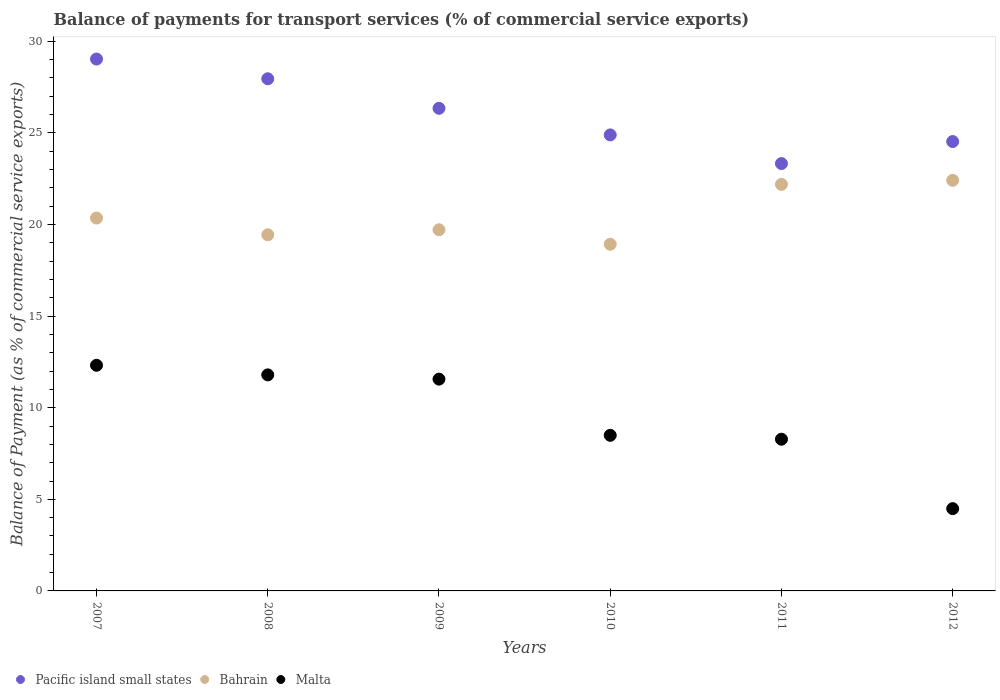How many different coloured dotlines are there?
Ensure brevity in your answer.  3. Is the number of dotlines equal to the number of legend labels?
Your answer should be very brief. Yes. What is the balance of payments for transport services in Bahrain in 2009?
Your answer should be compact. 19.72. Across all years, what is the maximum balance of payments for transport services in Pacific island small states?
Ensure brevity in your answer.  29.03. Across all years, what is the minimum balance of payments for transport services in Bahrain?
Your answer should be very brief. 18.92. In which year was the balance of payments for transport services in Malta maximum?
Provide a short and direct response. 2007. What is the total balance of payments for transport services in Bahrain in the graph?
Provide a short and direct response. 123.04. What is the difference between the balance of payments for transport services in Bahrain in 2008 and that in 2011?
Ensure brevity in your answer.  -2.75. What is the difference between the balance of payments for transport services in Pacific island small states in 2008 and the balance of payments for transport services in Bahrain in 2010?
Provide a short and direct response. 9.03. What is the average balance of payments for transport services in Malta per year?
Offer a very short reply. 9.49. In the year 2008, what is the difference between the balance of payments for transport services in Pacific island small states and balance of payments for transport services in Bahrain?
Make the answer very short. 8.52. What is the ratio of the balance of payments for transport services in Pacific island small states in 2007 to that in 2009?
Give a very brief answer. 1.1. What is the difference between the highest and the second highest balance of payments for transport services in Bahrain?
Make the answer very short. 0.22. What is the difference between the highest and the lowest balance of payments for transport services in Bahrain?
Provide a short and direct response. 3.49. Is the balance of payments for transport services in Bahrain strictly greater than the balance of payments for transport services in Malta over the years?
Provide a short and direct response. Yes. Is the balance of payments for transport services in Malta strictly less than the balance of payments for transport services in Pacific island small states over the years?
Your answer should be compact. Yes. What is the difference between two consecutive major ticks on the Y-axis?
Give a very brief answer. 5. Are the values on the major ticks of Y-axis written in scientific E-notation?
Make the answer very short. No. Where does the legend appear in the graph?
Make the answer very short. Bottom left. How many legend labels are there?
Offer a very short reply. 3. What is the title of the graph?
Your answer should be compact. Balance of payments for transport services (% of commercial service exports). Does "Togo" appear as one of the legend labels in the graph?
Keep it short and to the point. No. What is the label or title of the Y-axis?
Ensure brevity in your answer.  Balance of Payment (as % of commercial service exports). What is the Balance of Payment (as % of commercial service exports) of Pacific island small states in 2007?
Your response must be concise. 29.03. What is the Balance of Payment (as % of commercial service exports) in Bahrain in 2007?
Your answer should be very brief. 20.35. What is the Balance of Payment (as % of commercial service exports) of Malta in 2007?
Provide a short and direct response. 12.32. What is the Balance of Payment (as % of commercial service exports) in Pacific island small states in 2008?
Offer a terse response. 27.96. What is the Balance of Payment (as % of commercial service exports) in Bahrain in 2008?
Offer a terse response. 19.44. What is the Balance of Payment (as % of commercial service exports) of Malta in 2008?
Keep it short and to the point. 11.79. What is the Balance of Payment (as % of commercial service exports) in Pacific island small states in 2009?
Your answer should be very brief. 26.34. What is the Balance of Payment (as % of commercial service exports) in Bahrain in 2009?
Your answer should be compact. 19.72. What is the Balance of Payment (as % of commercial service exports) in Malta in 2009?
Provide a succinct answer. 11.56. What is the Balance of Payment (as % of commercial service exports) of Pacific island small states in 2010?
Give a very brief answer. 24.89. What is the Balance of Payment (as % of commercial service exports) of Bahrain in 2010?
Make the answer very short. 18.92. What is the Balance of Payment (as % of commercial service exports) of Malta in 2010?
Your response must be concise. 8.49. What is the Balance of Payment (as % of commercial service exports) in Pacific island small states in 2011?
Offer a terse response. 23.33. What is the Balance of Payment (as % of commercial service exports) in Bahrain in 2011?
Your answer should be compact. 22.19. What is the Balance of Payment (as % of commercial service exports) in Malta in 2011?
Ensure brevity in your answer.  8.28. What is the Balance of Payment (as % of commercial service exports) of Pacific island small states in 2012?
Provide a short and direct response. 24.53. What is the Balance of Payment (as % of commercial service exports) in Bahrain in 2012?
Make the answer very short. 22.41. What is the Balance of Payment (as % of commercial service exports) in Malta in 2012?
Your answer should be compact. 4.49. Across all years, what is the maximum Balance of Payment (as % of commercial service exports) in Pacific island small states?
Offer a very short reply. 29.03. Across all years, what is the maximum Balance of Payment (as % of commercial service exports) in Bahrain?
Make the answer very short. 22.41. Across all years, what is the maximum Balance of Payment (as % of commercial service exports) of Malta?
Keep it short and to the point. 12.32. Across all years, what is the minimum Balance of Payment (as % of commercial service exports) of Pacific island small states?
Give a very brief answer. 23.33. Across all years, what is the minimum Balance of Payment (as % of commercial service exports) in Bahrain?
Your answer should be very brief. 18.92. Across all years, what is the minimum Balance of Payment (as % of commercial service exports) of Malta?
Keep it short and to the point. 4.49. What is the total Balance of Payment (as % of commercial service exports) of Pacific island small states in the graph?
Your response must be concise. 156.09. What is the total Balance of Payment (as % of commercial service exports) in Bahrain in the graph?
Make the answer very short. 123.04. What is the total Balance of Payment (as % of commercial service exports) of Malta in the graph?
Provide a succinct answer. 56.94. What is the difference between the Balance of Payment (as % of commercial service exports) in Pacific island small states in 2007 and that in 2008?
Give a very brief answer. 1.08. What is the difference between the Balance of Payment (as % of commercial service exports) of Bahrain in 2007 and that in 2008?
Offer a very short reply. 0.92. What is the difference between the Balance of Payment (as % of commercial service exports) of Malta in 2007 and that in 2008?
Offer a terse response. 0.52. What is the difference between the Balance of Payment (as % of commercial service exports) of Pacific island small states in 2007 and that in 2009?
Make the answer very short. 2.69. What is the difference between the Balance of Payment (as % of commercial service exports) in Bahrain in 2007 and that in 2009?
Offer a very short reply. 0.64. What is the difference between the Balance of Payment (as % of commercial service exports) of Malta in 2007 and that in 2009?
Provide a short and direct response. 0.76. What is the difference between the Balance of Payment (as % of commercial service exports) in Pacific island small states in 2007 and that in 2010?
Offer a very short reply. 4.14. What is the difference between the Balance of Payment (as % of commercial service exports) in Bahrain in 2007 and that in 2010?
Give a very brief answer. 1.43. What is the difference between the Balance of Payment (as % of commercial service exports) of Malta in 2007 and that in 2010?
Your answer should be compact. 3.82. What is the difference between the Balance of Payment (as % of commercial service exports) of Pacific island small states in 2007 and that in 2011?
Your response must be concise. 5.71. What is the difference between the Balance of Payment (as % of commercial service exports) in Bahrain in 2007 and that in 2011?
Make the answer very short. -1.84. What is the difference between the Balance of Payment (as % of commercial service exports) of Malta in 2007 and that in 2011?
Offer a terse response. 4.04. What is the difference between the Balance of Payment (as % of commercial service exports) of Pacific island small states in 2007 and that in 2012?
Your answer should be very brief. 4.5. What is the difference between the Balance of Payment (as % of commercial service exports) of Bahrain in 2007 and that in 2012?
Ensure brevity in your answer.  -2.06. What is the difference between the Balance of Payment (as % of commercial service exports) of Malta in 2007 and that in 2012?
Provide a succinct answer. 7.83. What is the difference between the Balance of Payment (as % of commercial service exports) in Pacific island small states in 2008 and that in 2009?
Keep it short and to the point. 1.61. What is the difference between the Balance of Payment (as % of commercial service exports) of Bahrain in 2008 and that in 2009?
Your answer should be compact. -0.28. What is the difference between the Balance of Payment (as % of commercial service exports) of Malta in 2008 and that in 2009?
Give a very brief answer. 0.23. What is the difference between the Balance of Payment (as % of commercial service exports) of Pacific island small states in 2008 and that in 2010?
Your answer should be very brief. 3.06. What is the difference between the Balance of Payment (as % of commercial service exports) in Bahrain in 2008 and that in 2010?
Offer a very short reply. 0.52. What is the difference between the Balance of Payment (as % of commercial service exports) of Malta in 2008 and that in 2010?
Provide a succinct answer. 3.3. What is the difference between the Balance of Payment (as % of commercial service exports) in Pacific island small states in 2008 and that in 2011?
Offer a terse response. 4.63. What is the difference between the Balance of Payment (as % of commercial service exports) of Bahrain in 2008 and that in 2011?
Make the answer very short. -2.75. What is the difference between the Balance of Payment (as % of commercial service exports) in Malta in 2008 and that in 2011?
Keep it short and to the point. 3.51. What is the difference between the Balance of Payment (as % of commercial service exports) in Pacific island small states in 2008 and that in 2012?
Keep it short and to the point. 3.43. What is the difference between the Balance of Payment (as % of commercial service exports) in Bahrain in 2008 and that in 2012?
Your response must be concise. -2.97. What is the difference between the Balance of Payment (as % of commercial service exports) in Malta in 2008 and that in 2012?
Keep it short and to the point. 7.3. What is the difference between the Balance of Payment (as % of commercial service exports) of Pacific island small states in 2009 and that in 2010?
Give a very brief answer. 1.45. What is the difference between the Balance of Payment (as % of commercial service exports) of Bahrain in 2009 and that in 2010?
Provide a short and direct response. 0.79. What is the difference between the Balance of Payment (as % of commercial service exports) of Malta in 2009 and that in 2010?
Ensure brevity in your answer.  3.07. What is the difference between the Balance of Payment (as % of commercial service exports) of Pacific island small states in 2009 and that in 2011?
Your answer should be compact. 3.02. What is the difference between the Balance of Payment (as % of commercial service exports) of Bahrain in 2009 and that in 2011?
Provide a succinct answer. -2.48. What is the difference between the Balance of Payment (as % of commercial service exports) of Malta in 2009 and that in 2011?
Provide a short and direct response. 3.28. What is the difference between the Balance of Payment (as % of commercial service exports) in Pacific island small states in 2009 and that in 2012?
Keep it short and to the point. 1.81. What is the difference between the Balance of Payment (as % of commercial service exports) of Bahrain in 2009 and that in 2012?
Your answer should be compact. -2.7. What is the difference between the Balance of Payment (as % of commercial service exports) in Malta in 2009 and that in 2012?
Ensure brevity in your answer.  7.07. What is the difference between the Balance of Payment (as % of commercial service exports) in Pacific island small states in 2010 and that in 2011?
Provide a short and direct response. 1.56. What is the difference between the Balance of Payment (as % of commercial service exports) in Bahrain in 2010 and that in 2011?
Make the answer very short. -3.27. What is the difference between the Balance of Payment (as % of commercial service exports) of Malta in 2010 and that in 2011?
Your answer should be very brief. 0.21. What is the difference between the Balance of Payment (as % of commercial service exports) in Pacific island small states in 2010 and that in 2012?
Ensure brevity in your answer.  0.36. What is the difference between the Balance of Payment (as % of commercial service exports) in Bahrain in 2010 and that in 2012?
Your answer should be compact. -3.49. What is the difference between the Balance of Payment (as % of commercial service exports) in Malta in 2010 and that in 2012?
Ensure brevity in your answer.  4. What is the difference between the Balance of Payment (as % of commercial service exports) of Pacific island small states in 2011 and that in 2012?
Offer a terse response. -1.2. What is the difference between the Balance of Payment (as % of commercial service exports) of Bahrain in 2011 and that in 2012?
Give a very brief answer. -0.22. What is the difference between the Balance of Payment (as % of commercial service exports) of Malta in 2011 and that in 2012?
Offer a very short reply. 3.79. What is the difference between the Balance of Payment (as % of commercial service exports) in Pacific island small states in 2007 and the Balance of Payment (as % of commercial service exports) in Bahrain in 2008?
Provide a succinct answer. 9.59. What is the difference between the Balance of Payment (as % of commercial service exports) of Pacific island small states in 2007 and the Balance of Payment (as % of commercial service exports) of Malta in 2008?
Ensure brevity in your answer.  17.24. What is the difference between the Balance of Payment (as % of commercial service exports) in Bahrain in 2007 and the Balance of Payment (as % of commercial service exports) in Malta in 2008?
Offer a terse response. 8.56. What is the difference between the Balance of Payment (as % of commercial service exports) of Pacific island small states in 2007 and the Balance of Payment (as % of commercial service exports) of Bahrain in 2009?
Offer a very short reply. 9.32. What is the difference between the Balance of Payment (as % of commercial service exports) in Pacific island small states in 2007 and the Balance of Payment (as % of commercial service exports) in Malta in 2009?
Keep it short and to the point. 17.47. What is the difference between the Balance of Payment (as % of commercial service exports) in Bahrain in 2007 and the Balance of Payment (as % of commercial service exports) in Malta in 2009?
Your response must be concise. 8.79. What is the difference between the Balance of Payment (as % of commercial service exports) in Pacific island small states in 2007 and the Balance of Payment (as % of commercial service exports) in Bahrain in 2010?
Offer a terse response. 10.11. What is the difference between the Balance of Payment (as % of commercial service exports) of Pacific island small states in 2007 and the Balance of Payment (as % of commercial service exports) of Malta in 2010?
Ensure brevity in your answer.  20.54. What is the difference between the Balance of Payment (as % of commercial service exports) in Bahrain in 2007 and the Balance of Payment (as % of commercial service exports) in Malta in 2010?
Your answer should be very brief. 11.86. What is the difference between the Balance of Payment (as % of commercial service exports) in Pacific island small states in 2007 and the Balance of Payment (as % of commercial service exports) in Bahrain in 2011?
Provide a short and direct response. 6.84. What is the difference between the Balance of Payment (as % of commercial service exports) of Pacific island small states in 2007 and the Balance of Payment (as % of commercial service exports) of Malta in 2011?
Give a very brief answer. 20.75. What is the difference between the Balance of Payment (as % of commercial service exports) in Bahrain in 2007 and the Balance of Payment (as % of commercial service exports) in Malta in 2011?
Give a very brief answer. 12.07. What is the difference between the Balance of Payment (as % of commercial service exports) of Pacific island small states in 2007 and the Balance of Payment (as % of commercial service exports) of Bahrain in 2012?
Give a very brief answer. 6.62. What is the difference between the Balance of Payment (as % of commercial service exports) of Pacific island small states in 2007 and the Balance of Payment (as % of commercial service exports) of Malta in 2012?
Your answer should be compact. 24.54. What is the difference between the Balance of Payment (as % of commercial service exports) of Bahrain in 2007 and the Balance of Payment (as % of commercial service exports) of Malta in 2012?
Offer a very short reply. 15.86. What is the difference between the Balance of Payment (as % of commercial service exports) of Pacific island small states in 2008 and the Balance of Payment (as % of commercial service exports) of Bahrain in 2009?
Make the answer very short. 8.24. What is the difference between the Balance of Payment (as % of commercial service exports) in Pacific island small states in 2008 and the Balance of Payment (as % of commercial service exports) in Malta in 2009?
Offer a very short reply. 16.4. What is the difference between the Balance of Payment (as % of commercial service exports) of Bahrain in 2008 and the Balance of Payment (as % of commercial service exports) of Malta in 2009?
Keep it short and to the point. 7.88. What is the difference between the Balance of Payment (as % of commercial service exports) in Pacific island small states in 2008 and the Balance of Payment (as % of commercial service exports) in Bahrain in 2010?
Your response must be concise. 9.03. What is the difference between the Balance of Payment (as % of commercial service exports) of Pacific island small states in 2008 and the Balance of Payment (as % of commercial service exports) of Malta in 2010?
Offer a terse response. 19.46. What is the difference between the Balance of Payment (as % of commercial service exports) in Bahrain in 2008 and the Balance of Payment (as % of commercial service exports) in Malta in 2010?
Give a very brief answer. 10.94. What is the difference between the Balance of Payment (as % of commercial service exports) of Pacific island small states in 2008 and the Balance of Payment (as % of commercial service exports) of Bahrain in 2011?
Your answer should be compact. 5.77. What is the difference between the Balance of Payment (as % of commercial service exports) of Pacific island small states in 2008 and the Balance of Payment (as % of commercial service exports) of Malta in 2011?
Keep it short and to the point. 19.68. What is the difference between the Balance of Payment (as % of commercial service exports) in Bahrain in 2008 and the Balance of Payment (as % of commercial service exports) in Malta in 2011?
Provide a succinct answer. 11.16. What is the difference between the Balance of Payment (as % of commercial service exports) of Pacific island small states in 2008 and the Balance of Payment (as % of commercial service exports) of Bahrain in 2012?
Ensure brevity in your answer.  5.54. What is the difference between the Balance of Payment (as % of commercial service exports) in Pacific island small states in 2008 and the Balance of Payment (as % of commercial service exports) in Malta in 2012?
Make the answer very short. 23.47. What is the difference between the Balance of Payment (as % of commercial service exports) in Bahrain in 2008 and the Balance of Payment (as % of commercial service exports) in Malta in 2012?
Offer a terse response. 14.95. What is the difference between the Balance of Payment (as % of commercial service exports) of Pacific island small states in 2009 and the Balance of Payment (as % of commercial service exports) of Bahrain in 2010?
Ensure brevity in your answer.  7.42. What is the difference between the Balance of Payment (as % of commercial service exports) of Pacific island small states in 2009 and the Balance of Payment (as % of commercial service exports) of Malta in 2010?
Ensure brevity in your answer.  17.85. What is the difference between the Balance of Payment (as % of commercial service exports) in Bahrain in 2009 and the Balance of Payment (as % of commercial service exports) in Malta in 2010?
Provide a short and direct response. 11.22. What is the difference between the Balance of Payment (as % of commercial service exports) in Pacific island small states in 2009 and the Balance of Payment (as % of commercial service exports) in Bahrain in 2011?
Provide a succinct answer. 4.15. What is the difference between the Balance of Payment (as % of commercial service exports) of Pacific island small states in 2009 and the Balance of Payment (as % of commercial service exports) of Malta in 2011?
Offer a terse response. 18.06. What is the difference between the Balance of Payment (as % of commercial service exports) in Bahrain in 2009 and the Balance of Payment (as % of commercial service exports) in Malta in 2011?
Make the answer very short. 11.43. What is the difference between the Balance of Payment (as % of commercial service exports) in Pacific island small states in 2009 and the Balance of Payment (as % of commercial service exports) in Bahrain in 2012?
Give a very brief answer. 3.93. What is the difference between the Balance of Payment (as % of commercial service exports) in Pacific island small states in 2009 and the Balance of Payment (as % of commercial service exports) in Malta in 2012?
Ensure brevity in your answer.  21.85. What is the difference between the Balance of Payment (as % of commercial service exports) in Bahrain in 2009 and the Balance of Payment (as % of commercial service exports) in Malta in 2012?
Your answer should be compact. 15.22. What is the difference between the Balance of Payment (as % of commercial service exports) in Pacific island small states in 2010 and the Balance of Payment (as % of commercial service exports) in Bahrain in 2011?
Give a very brief answer. 2.7. What is the difference between the Balance of Payment (as % of commercial service exports) of Pacific island small states in 2010 and the Balance of Payment (as % of commercial service exports) of Malta in 2011?
Make the answer very short. 16.61. What is the difference between the Balance of Payment (as % of commercial service exports) of Bahrain in 2010 and the Balance of Payment (as % of commercial service exports) of Malta in 2011?
Offer a terse response. 10.64. What is the difference between the Balance of Payment (as % of commercial service exports) in Pacific island small states in 2010 and the Balance of Payment (as % of commercial service exports) in Bahrain in 2012?
Make the answer very short. 2.48. What is the difference between the Balance of Payment (as % of commercial service exports) of Pacific island small states in 2010 and the Balance of Payment (as % of commercial service exports) of Malta in 2012?
Make the answer very short. 20.4. What is the difference between the Balance of Payment (as % of commercial service exports) of Bahrain in 2010 and the Balance of Payment (as % of commercial service exports) of Malta in 2012?
Give a very brief answer. 14.43. What is the difference between the Balance of Payment (as % of commercial service exports) of Pacific island small states in 2011 and the Balance of Payment (as % of commercial service exports) of Bahrain in 2012?
Your answer should be very brief. 0.91. What is the difference between the Balance of Payment (as % of commercial service exports) of Pacific island small states in 2011 and the Balance of Payment (as % of commercial service exports) of Malta in 2012?
Your answer should be compact. 18.84. What is the difference between the Balance of Payment (as % of commercial service exports) of Bahrain in 2011 and the Balance of Payment (as % of commercial service exports) of Malta in 2012?
Your response must be concise. 17.7. What is the average Balance of Payment (as % of commercial service exports) of Pacific island small states per year?
Make the answer very short. 26.01. What is the average Balance of Payment (as % of commercial service exports) of Bahrain per year?
Ensure brevity in your answer.  20.51. What is the average Balance of Payment (as % of commercial service exports) in Malta per year?
Your response must be concise. 9.49. In the year 2007, what is the difference between the Balance of Payment (as % of commercial service exports) in Pacific island small states and Balance of Payment (as % of commercial service exports) in Bahrain?
Your answer should be compact. 8.68. In the year 2007, what is the difference between the Balance of Payment (as % of commercial service exports) in Pacific island small states and Balance of Payment (as % of commercial service exports) in Malta?
Make the answer very short. 16.72. In the year 2007, what is the difference between the Balance of Payment (as % of commercial service exports) in Bahrain and Balance of Payment (as % of commercial service exports) in Malta?
Give a very brief answer. 8.04. In the year 2008, what is the difference between the Balance of Payment (as % of commercial service exports) of Pacific island small states and Balance of Payment (as % of commercial service exports) of Bahrain?
Offer a very short reply. 8.52. In the year 2008, what is the difference between the Balance of Payment (as % of commercial service exports) in Pacific island small states and Balance of Payment (as % of commercial service exports) in Malta?
Your answer should be very brief. 16.16. In the year 2008, what is the difference between the Balance of Payment (as % of commercial service exports) of Bahrain and Balance of Payment (as % of commercial service exports) of Malta?
Keep it short and to the point. 7.65. In the year 2009, what is the difference between the Balance of Payment (as % of commercial service exports) of Pacific island small states and Balance of Payment (as % of commercial service exports) of Bahrain?
Make the answer very short. 6.63. In the year 2009, what is the difference between the Balance of Payment (as % of commercial service exports) of Pacific island small states and Balance of Payment (as % of commercial service exports) of Malta?
Your answer should be compact. 14.78. In the year 2009, what is the difference between the Balance of Payment (as % of commercial service exports) of Bahrain and Balance of Payment (as % of commercial service exports) of Malta?
Your answer should be very brief. 8.15. In the year 2010, what is the difference between the Balance of Payment (as % of commercial service exports) of Pacific island small states and Balance of Payment (as % of commercial service exports) of Bahrain?
Make the answer very short. 5.97. In the year 2010, what is the difference between the Balance of Payment (as % of commercial service exports) of Pacific island small states and Balance of Payment (as % of commercial service exports) of Malta?
Ensure brevity in your answer.  16.4. In the year 2010, what is the difference between the Balance of Payment (as % of commercial service exports) in Bahrain and Balance of Payment (as % of commercial service exports) in Malta?
Keep it short and to the point. 10.43. In the year 2011, what is the difference between the Balance of Payment (as % of commercial service exports) of Pacific island small states and Balance of Payment (as % of commercial service exports) of Bahrain?
Your answer should be compact. 1.14. In the year 2011, what is the difference between the Balance of Payment (as % of commercial service exports) in Pacific island small states and Balance of Payment (as % of commercial service exports) in Malta?
Offer a terse response. 15.05. In the year 2011, what is the difference between the Balance of Payment (as % of commercial service exports) of Bahrain and Balance of Payment (as % of commercial service exports) of Malta?
Offer a terse response. 13.91. In the year 2012, what is the difference between the Balance of Payment (as % of commercial service exports) in Pacific island small states and Balance of Payment (as % of commercial service exports) in Bahrain?
Give a very brief answer. 2.12. In the year 2012, what is the difference between the Balance of Payment (as % of commercial service exports) of Pacific island small states and Balance of Payment (as % of commercial service exports) of Malta?
Your response must be concise. 20.04. In the year 2012, what is the difference between the Balance of Payment (as % of commercial service exports) in Bahrain and Balance of Payment (as % of commercial service exports) in Malta?
Make the answer very short. 17.92. What is the ratio of the Balance of Payment (as % of commercial service exports) in Bahrain in 2007 to that in 2008?
Offer a terse response. 1.05. What is the ratio of the Balance of Payment (as % of commercial service exports) of Malta in 2007 to that in 2008?
Your response must be concise. 1.04. What is the ratio of the Balance of Payment (as % of commercial service exports) in Pacific island small states in 2007 to that in 2009?
Keep it short and to the point. 1.1. What is the ratio of the Balance of Payment (as % of commercial service exports) of Bahrain in 2007 to that in 2009?
Provide a succinct answer. 1.03. What is the ratio of the Balance of Payment (as % of commercial service exports) of Malta in 2007 to that in 2009?
Provide a succinct answer. 1.07. What is the ratio of the Balance of Payment (as % of commercial service exports) of Pacific island small states in 2007 to that in 2010?
Make the answer very short. 1.17. What is the ratio of the Balance of Payment (as % of commercial service exports) in Bahrain in 2007 to that in 2010?
Give a very brief answer. 1.08. What is the ratio of the Balance of Payment (as % of commercial service exports) of Malta in 2007 to that in 2010?
Provide a succinct answer. 1.45. What is the ratio of the Balance of Payment (as % of commercial service exports) in Pacific island small states in 2007 to that in 2011?
Offer a terse response. 1.24. What is the ratio of the Balance of Payment (as % of commercial service exports) of Bahrain in 2007 to that in 2011?
Provide a succinct answer. 0.92. What is the ratio of the Balance of Payment (as % of commercial service exports) of Malta in 2007 to that in 2011?
Provide a short and direct response. 1.49. What is the ratio of the Balance of Payment (as % of commercial service exports) in Pacific island small states in 2007 to that in 2012?
Provide a short and direct response. 1.18. What is the ratio of the Balance of Payment (as % of commercial service exports) in Bahrain in 2007 to that in 2012?
Give a very brief answer. 0.91. What is the ratio of the Balance of Payment (as % of commercial service exports) in Malta in 2007 to that in 2012?
Give a very brief answer. 2.74. What is the ratio of the Balance of Payment (as % of commercial service exports) of Pacific island small states in 2008 to that in 2009?
Provide a succinct answer. 1.06. What is the ratio of the Balance of Payment (as % of commercial service exports) of Malta in 2008 to that in 2009?
Make the answer very short. 1.02. What is the ratio of the Balance of Payment (as % of commercial service exports) of Pacific island small states in 2008 to that in 2010?
Ensure brevity in your answer.  1.12. What is the ratio of the Balance of Payment (as % of commercial service exports) in Bahrain in 2008 to that in 2010?
Your response must be concise. 1.03. What is the ratio of the Balance of Payment (as % of commercial service exports) in Malta in 2008 to that in 2010?
Provide a succinct answer. 1.39. What is the ratio of the Balance of Payment (as % of commercial service exports) of Pacific island small states in 2008 to that in 2011?
Ensure brevity in your answer.  1.2. What is the ratio of the Balance of Payment (as % of commercial service exports) of Bahrain in 2008 to that in 2011?
Give a very brief answer. 0.88. What is the ratio of the Balance of Payment (as % of commercial service exports) of Malta in 2008 to that in 2011?
Your answer should be very brief. 1.42. What is the ratio of the Balance of Payment (as % of commercial service exports) in Pacific island small states in 2008 to that in 2012?
Give a very brief answer. 1.14. What is the ratio of the Balance of Payment (as % of commercial service exports) of Bahrain in 2008 to that in 2012?
Offer a very short reply. 0.87. What is the ratio of the Balance of Payment (as % of commercial service exports) in Malta in 2008 to that in 2012?
Your response must be concise. 2.63. What is the ratio of the Balance of Payment (as % of commercial service exports) of Pacific island small states in 2009 to that in 2010?
Make the answer very short. 1.06. What is the ratio of the Balance of Payment (as % of commercial service exports) in Bahrain in 2009 to that in 2010?
Make the answer very short. 1.04. What is the ratio of the Balance of Payment (as % of commercial service exports) of Malta in 2009 to that in 2010?
Your answer should be very brief. 1.36. What is the ratio of the Balance of Payment (as % of commercial service exports) in Pacific island small states in 2009 to that in 2011?
Your answer should be compact. 1.13. What is the ratio of the Balance of Payment (as % of commercial service exports) of Bahrain in 2009 to that in 2011?
Ensure brevity in your answer.  0.89. What is the ratio of the Balance of Payment (as % of commercial service exports) of Malta in 2009 to that in 2011?
Your answer should be compact. 1.4. What is the ratio of the Balance of Payment (as % of commercial service exports) in Pacific island small states in 2009 to that in 2012?
Ensure brevity in your answer.  1.07. What is the ratio of the Balance of Payment (as % of commercial service exports) of Bahrain in 2009 to that in 2012?
Make the answer very short. 0.88. What is the ratio of the Balance of Payment (as % of commercial service exports) of Malta in 2009 to that in 2012?
Your response must be concise. 2.57. What is the ratio of the Balance of Payment (as % of commercial service exports) of Pacific island small states in 2010 to that in 2011?
Ensure brevity in your answer.  1.07. What is the ratio of the Balance of Payment (as % of commercial service exports) in Bahrain in 2010 to that in 2011?
Your answer should be compact. 0.85. What is the ratio of the Balance of Payment (as % of commercial service exports) in Malta in 2010 to that in 2011?
Provide a succinct answer. 1.03. What is the ratio of the Balance of Payment (as % of commercial service exports) in Pacific island small states in 2010 to that in 2012?
Offer a terse response. 1.01. What is the ratio of the Balance of Payment (as % of commercial service exports) of Bahrain in 2010 to that in 2012?
Ensure brevity in your answer.  0.84. What is the ratio of the Balance of Payment (as % of commercial service exports) of Malta in 2010 to that in 2012?
Provide a short and direct response. 1.89. What is the ratio of the Balance of Payment (as % of commercial service exports) in Pacific island small states in 2011 to that in 2012?
Offer a very short reply. 0.95. What is the ratio of the Balance of Payment (as % of commercial service exports) in Bahrain in 2011 to that in 2012?
Offer a terse response. 0.99. What is the ratio of the Balance of Payment (as % of commercial service exports) in Malta in 2011 to that in 2012?
Your answer should be compact. 1.84. What is the difference between the highest and the second highest Balance of Payment (as % of commercial service exports) in Pacific island small states?
Offer a terse response. 1.08. What is the difference between the highest and the second highest Balance of Payment (as % of commercial service exports) of Bahrain?
Offer a terse response. 0.22. What is the difference between the highest and the second highest Balance of Payment (as % of commercial service exports) of Malta?
Provide a short and direct response. 0.52. What is the difference between the highest and the lowest Balance of Payment (as % of commercial service exports) of Pacific island small states?
Your answer should be very brief. 5.71. What is the difference between the highest and the lowest Balance of Payment (as % of commercial service exports) in Bahrain?
Keep it short and to the point. 3.49. What is the difference between the highest and the lowest Balance of Payment (as % of commercial service exports) in Malta?
Your response must be concise. 7.83. 